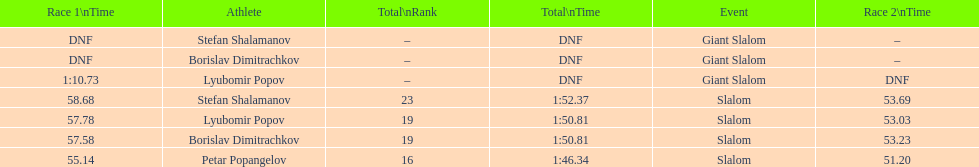Which athlete finished the first race but did not finish the second race? Lyubomir Popov. 